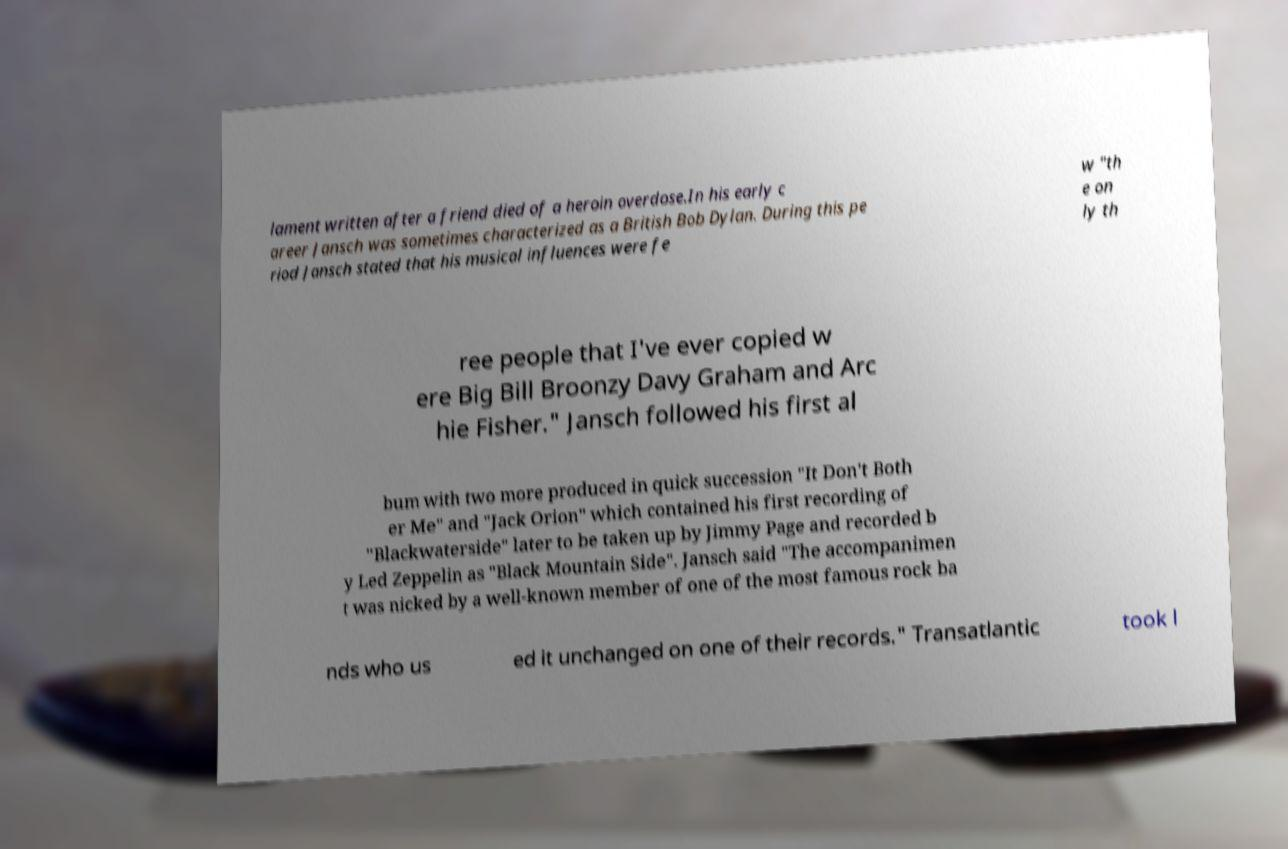Could you extract and type out the text from this image? lament written after a friend died of a heroin overdose.In his early c areer Jansch was sometimes characterized as a British Bob Dylan. During this pe riod Jansch stated that his musical influences were fe w "th e on ly th ree people that I've ever copied w ere Big Bill Broonzy Davy Graham and Arc hie Fisher." Jansch followed his first al bum with two more produced in quick succession "It Don't Both er Me" and "Jack Orion" which contained his first recording of "Blackwaterside" later to be taken up by Jimmy Page and recorded b y Led Zeppelin as "Black Mountain Side". Jansch said "The accompanimen t was nicked by a well-known member of one of the most famous rock ba nds who us ed it unchanged on one of their records." Transatlantic took l 